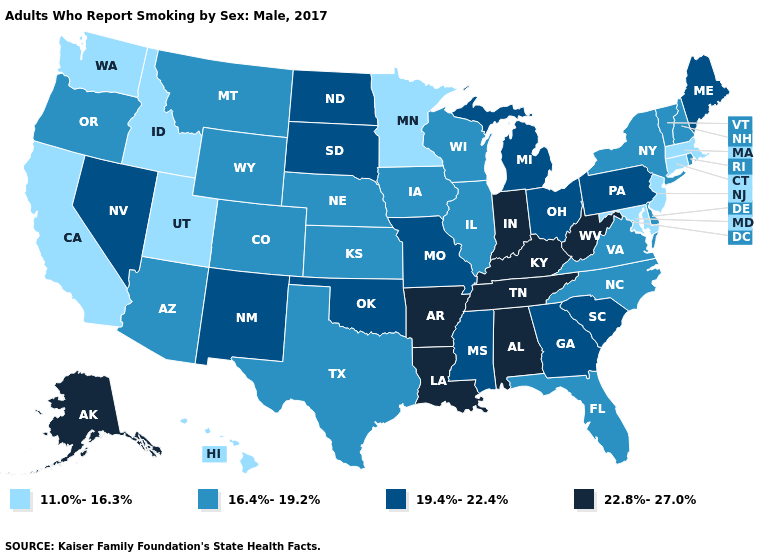Among the states that border Nevada , which have the lowest value?
Short answer required. California, Idaho, Utah. Name the states that have a value in the range 16.4%-19.2%?
Be succinct. Arizona, Colorado, Delaware, Florida, Illinois, Iowa, Kansas, Montana, Nebraska, New Hampshire, New York, North Carolina, Oregon, Rhode Island, Texas, Vermont, Virginia, Wisconsin, Wyoming. Does the first symbol in the legend represent the smallest category?
Keep it brief. Yes. Among the states that border New York , does Pennsylvania have the highest value?
Quick response, please. Yes. Which states have the lowest value in the USA?
Short answer required. California, Connecticut, Hawaii, Idaho, Maryland, Massachusetts, Minnesota, New Jersey, Utah, Washington. Does Wyoming have the same value as South Carolina?
Write a very short answer. No. Which states have the lowest value in the South?
Give a very brief answer. Maryland. What is the value of Arizona?
Concise answer only. 16.4%-19.2%. Which states have the lowest value in the South?
Short answer required. Maryland. Name the states that have a value in the range 11.0%-16.3%?
Keep it brief. California, Connecticut, Hawaii, Idaho, Maryland, Massachusetts, Minnesota, New Jersey, Utah, Washington. Among the states that border Maryland , which have the highest value?
Write a very short answer. West Virginia. What is the highest value in the USA?
Answer briefly. 22.8%-27.0%. Does Utah have the lowest value in the USA?
Short answer required. Yes. What is the value of New York?
Answer briefly. 16.4%-19.2%. Name the states that have a value in the range 19.4%-22.4%?
Be succinct. Georgia, Maine, Michigan, Mississippi, Missouri, Nevada, New Mexico, North Dakota, Ohio, Oklahoma, Pennsylvania, South Carolina, South Dakota. 